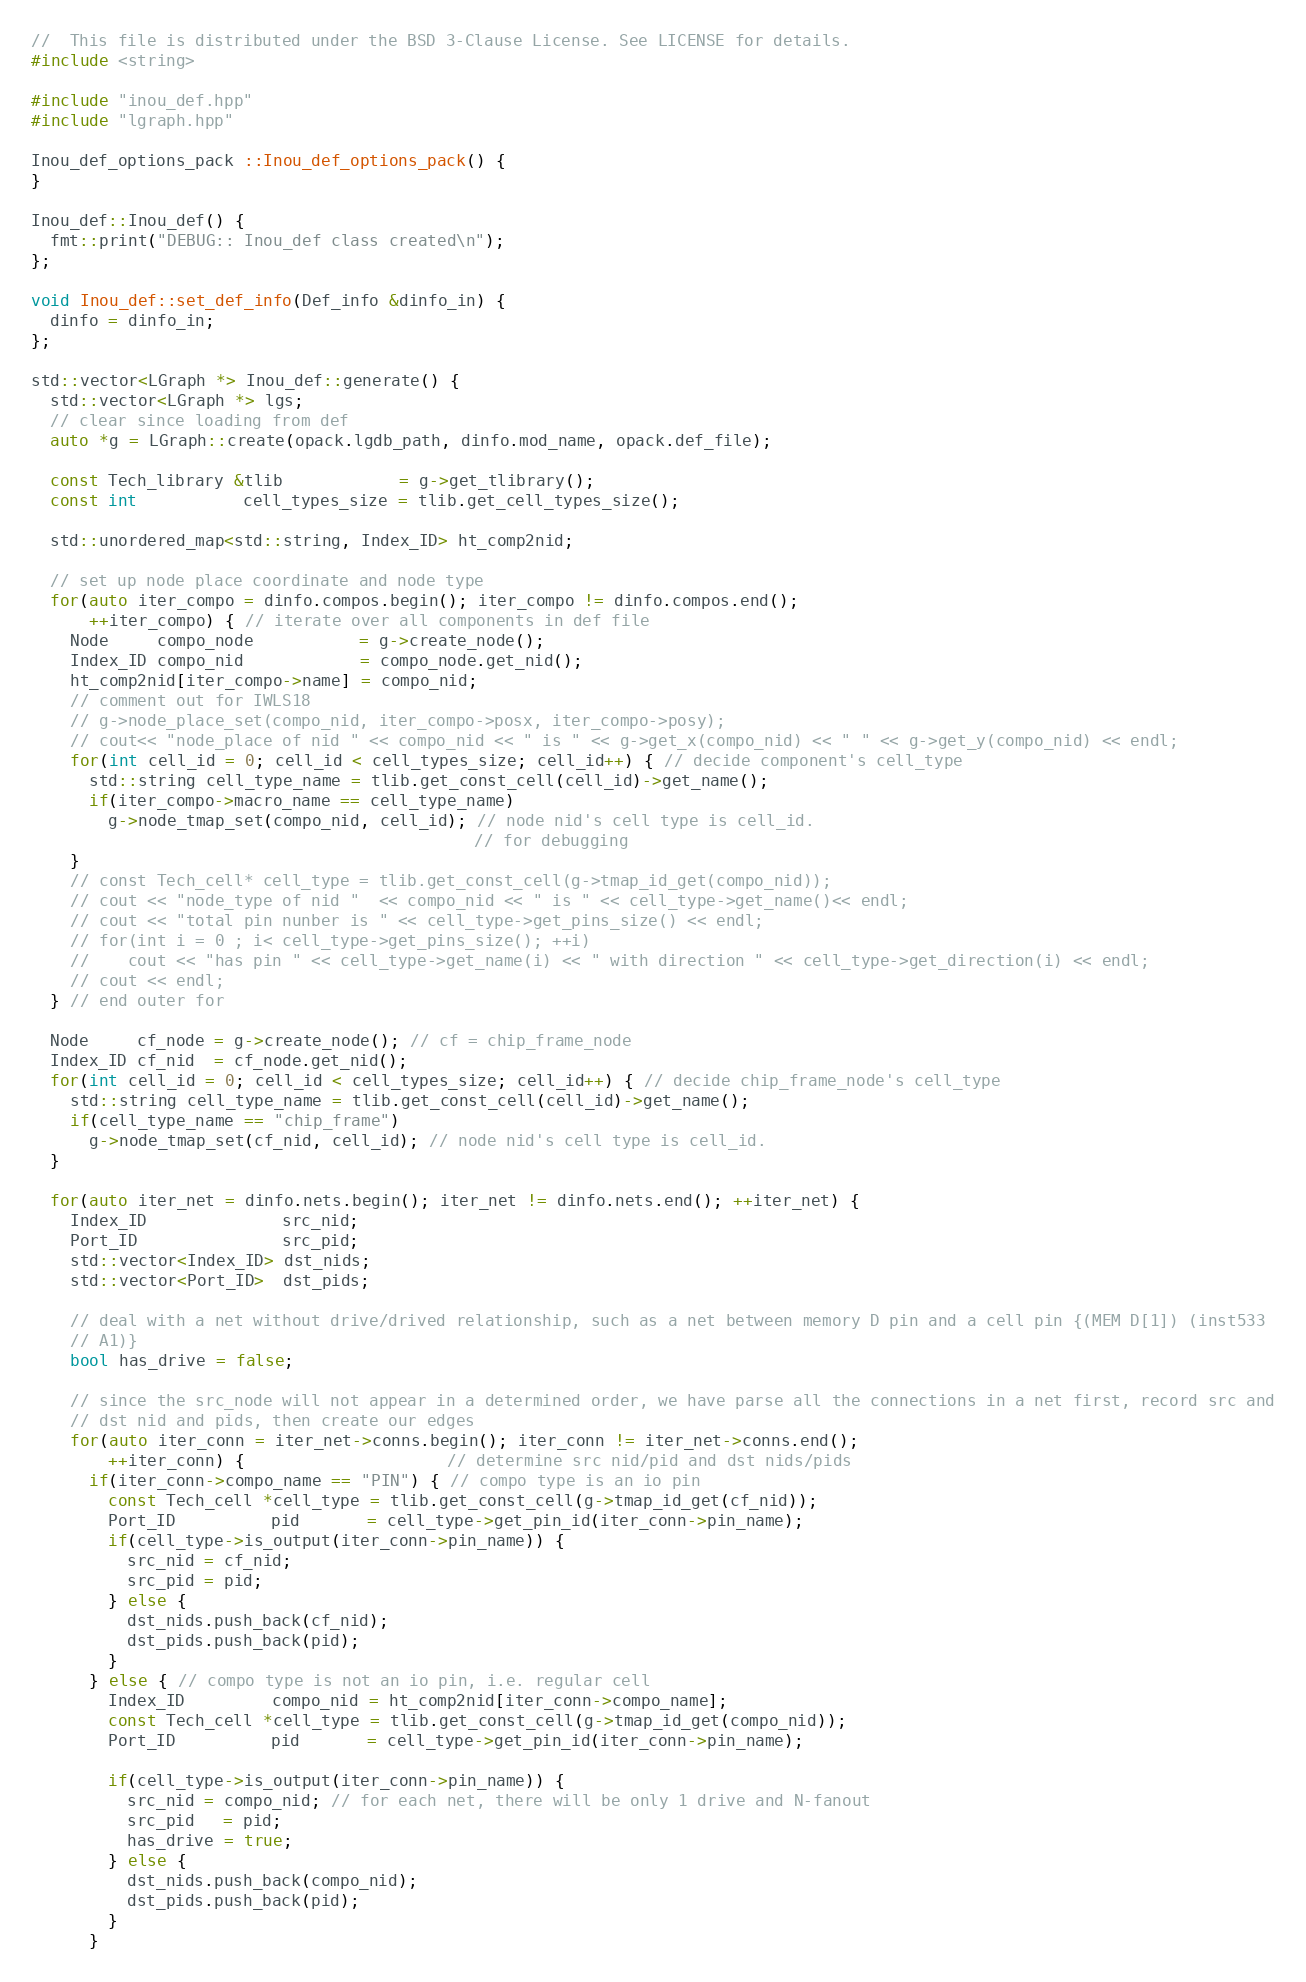<code> <loc_0><loc_0><loc_500><loc_500><_C++_>//  This file is distributed under the BSD 3-Clause License. See LICENSE for details.
#include <string>

#include "inou_def.hpp"
#include "lgraph.hpp"

Inou_def_options_pack ::Inou_def_options_pack() {
}

Inou_def::Inou_def() {
  fmt::print("DEBUG:: Inou_def class created\n");
};

void Inou_def::set_def_info(Def_info &dinfo_in) {
  dinfo = dinfo_in;
};

std::vector<LGraph *> Inou_def::generate() {
  std::vector<LGraph *> lgs;
  // clear since loading from def
  auto *g = LGraph::create(opack.lgdb_path, dinfo.mod_name, opack.def_file);

  const Tech_library &tlib            = g->get_tlibrary();
  const int           cell_types_size = tlib.get_cell_types_size();

  std::unordered_map<std::string, Index_ID> ht_comp2nid;

  // set up node place coordinate and node type
  for(auto iter_compo = dinfo.compos.begin(); iter_compo != dinfo.compos.end();
      ++iter_compo) { // iterate over all components in def file
    Node     compo_node           = g->create_node();
    Index_ID compo_nid            = compo_node.get_nid();
    ht_comp2nid[iter_compo->name] = compo_nid;
    // comment out for IWLS18
    // g->node_place_set(compo_nid, iter_compo->posx, iter_compo->posy);
    // cout<< "node_place of nid " << compo_nid << " is " << g->get_x(compo_nid) << " " << g->get_y(compo_nid) << endl;
    for(int cell_id = 0; cell_id < cell_types_size; cell_id++) { // decide component's cell_type
      std::string cell_type_name = tlib.get_const_cell(cell_id)->get_name();
      if(iter_compo->macro_name == cell_type_name)
        g->node_tmap_set(compo_nid, cell_id); // node nid's cell type is cell_id.
                                              // for debugging
    }
    // const Tech_cell* cell_type = tlib.get_const_cell(g->tmap_id_get(compo_nid));
    // cout << "node_type of nid "  << compo_nid << " is " << cell_type->get_name()<< endl;
    // cout << "total pin nunber is " << cell_type->get_pins_size() << endl;
    // for(int i = 0 ; i< cell_type->get_pins_size(); ++i)
    //    cout << "has pin " << cell_type->get_name(i) << " with direction " << cell_type->get_direction(i) << endl;
    // cout << endl;
  } // end outer for

  Node     cf_node = g->create_node(); // cf = chip_frame_node
  Index_ID cf_nid  = cf_node.get_nid();
  for(int cell_id = 0; cell_id < cell_types_size; cell_id++) { // decide chip_frame_node's cell_type
    std::string cell_type_name = tlib.get_const_cell(cell_id)->get_name();
    if(cell_type_name == "chip_frame")
      g->node_tmap_set(cf_nid, cell_id); // node nid's cell type is cell_id.
  }

  for(auto iter_net = dinfo.nets.begin(); iter_net != dinfo.nets.end(); ++iter_net) {
    Index_ID              src_nid;
    Port_ID               src_pid;
    std::vector<Index_ID> dst_nids;
    std::vector<Port_ID>  dst_pids;

    // deal with a net without drive/drived relationship, such as a net between memory D pin and a cell pin {(MEM D[1]) (inst533
    // A1)}
    bool has_drive = false;

    // since the src_node will not appear in a determined order, we have parse all the connections in a net first, record src and
    // dst nid and pids, then create our edges
    for(auto iter_conn = iter_net->conns.begin(); iter_conn != iter_net->conns.end();
        ++iter_conn) {                     // determine src nid/pid and dst nids/pids
      if(iter_conn->compo_name == "PIN") { // compo type is an io pin
        const Tech_cell *cell_type = tlib.get_const_cell(g->tmap_id_get(cf_nid));
        Port_ID          pid       = cell_type->get_pin_id(iter_conn->pin_name);
        if(cell_type->is_output(iter_conn->pin_name)) {
          src_nid = cf_nid;
          src_pid = pid;
        } else {
          dst_nids.push_back(cf_nid);
          dst_pids.push_back(pid);
        }
      } else { // compo type is not an io pin, i.e. regular cell
        Index_ID         compo_nid = ht_comp2nid[iter_conn->compo_name];
        const Tech_cell *cell_type = tlib.get_const_cell(g->tmap_id_get(compo_nid));
        Port_ID          pid       = cell_type->get_pin_id(iter_conn->pin_name);

        if(cell_type->is_output(iter_conn->pin_name)) {
          src_nid = compo_nid; // for each net, there will be only 1 drive and N-fanout
          src_pid   = pid;
          has_drive = true;
        } else {
          dst_nids.push_back(compo_nid);
          dst_pids.push_back(pid);
        }
      }</code> 